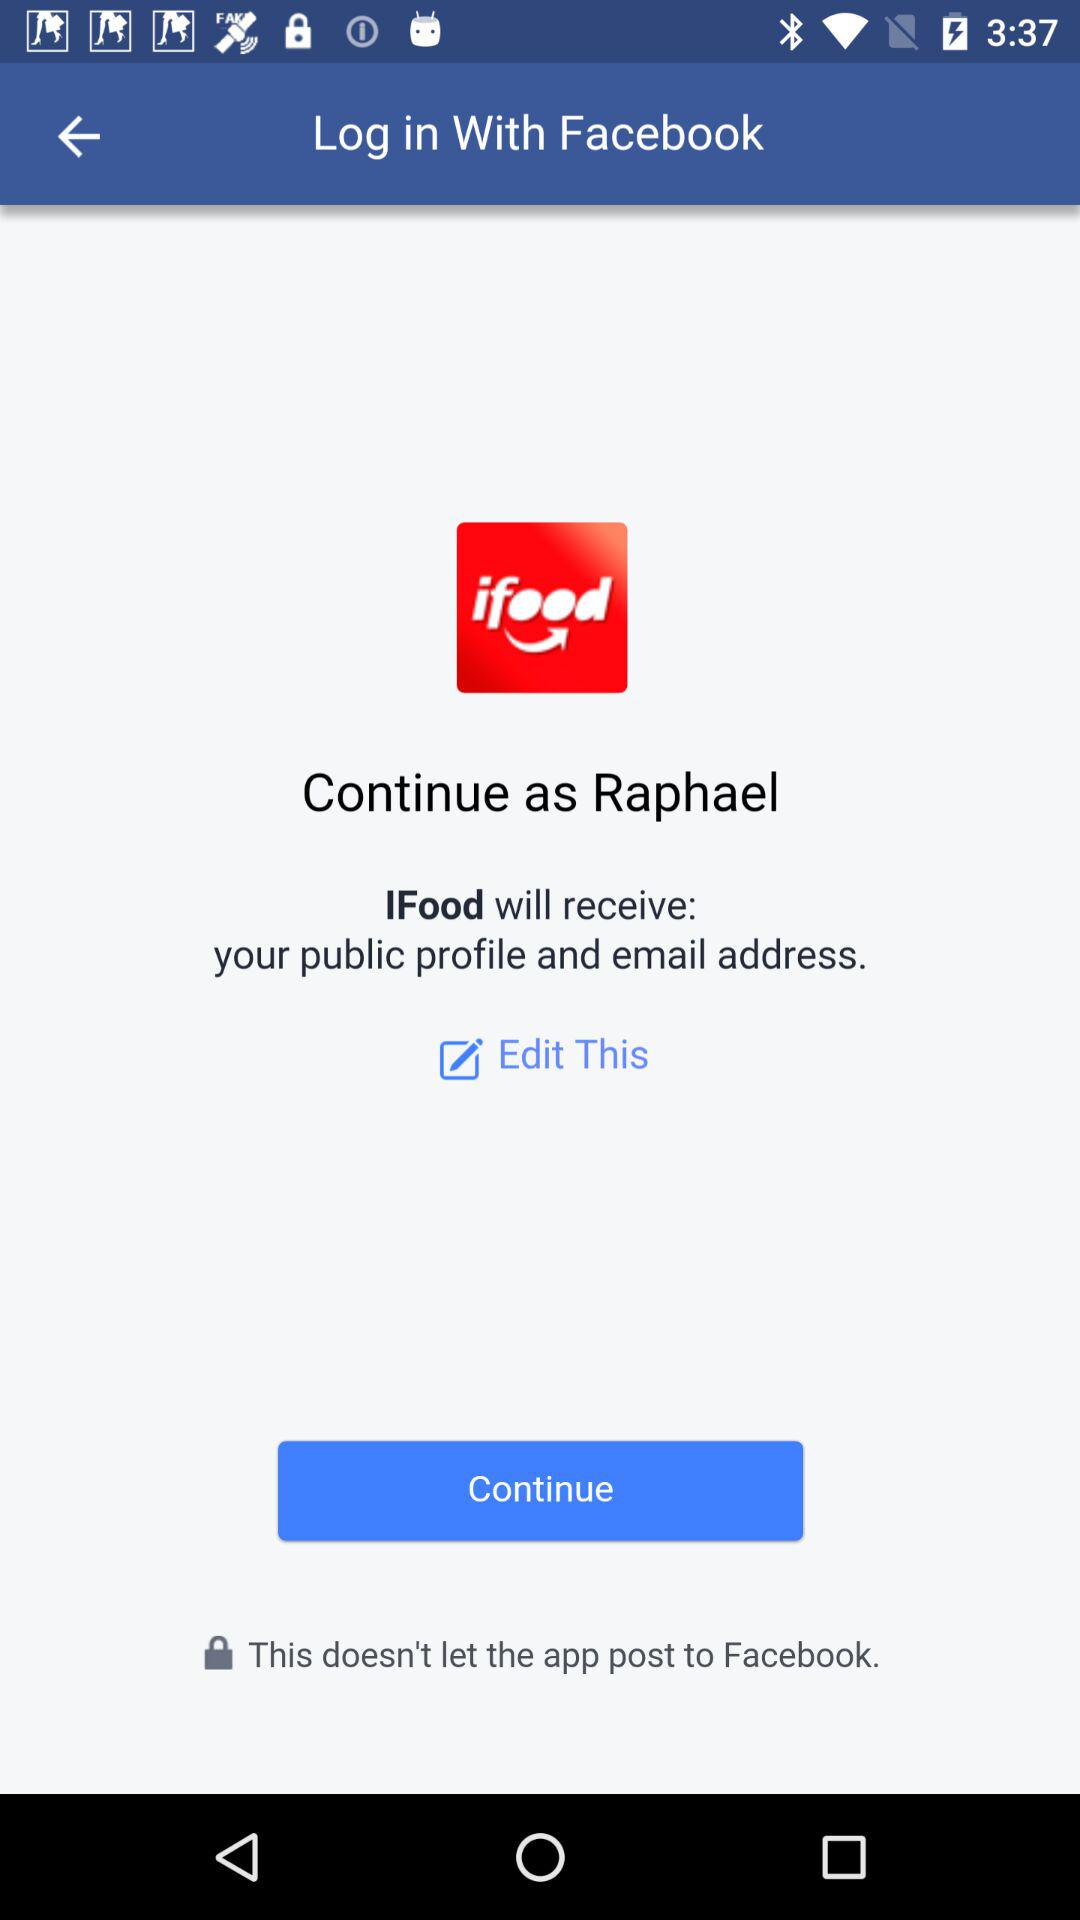What is the name of the user? The name of the user is Raphael. 